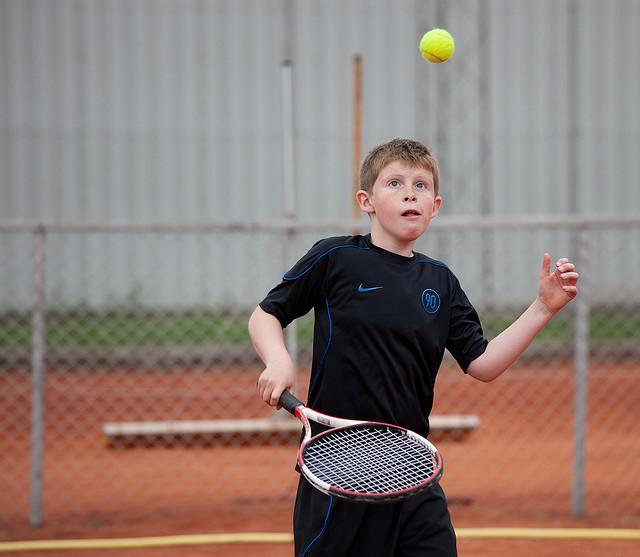Do you think he knows what he is doing?
Give a very brief answer. No. Did he miss or hit?
Keep it brief. Hit. Is he playing tennis?
Be succinct. Yes. Is the child concentrating?
Keep it brief. Yes. What is the person going to do?
Answer briefly. Hit ball. 